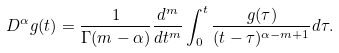<formula> <loc_0><loc_0><loc_500><loc_500>D ^ { \alpha } g ( t ) = \frac { 1 } { \Gamma ( m - \alpha ) } \frac { d ^ { m } } { d t ^ { m } } \int _ { 0 } ^ { t } \frac { g ( \tau ) } { ( t - \tau ) ^ { \alpha - m + 1 } } d \tau .</formula> 